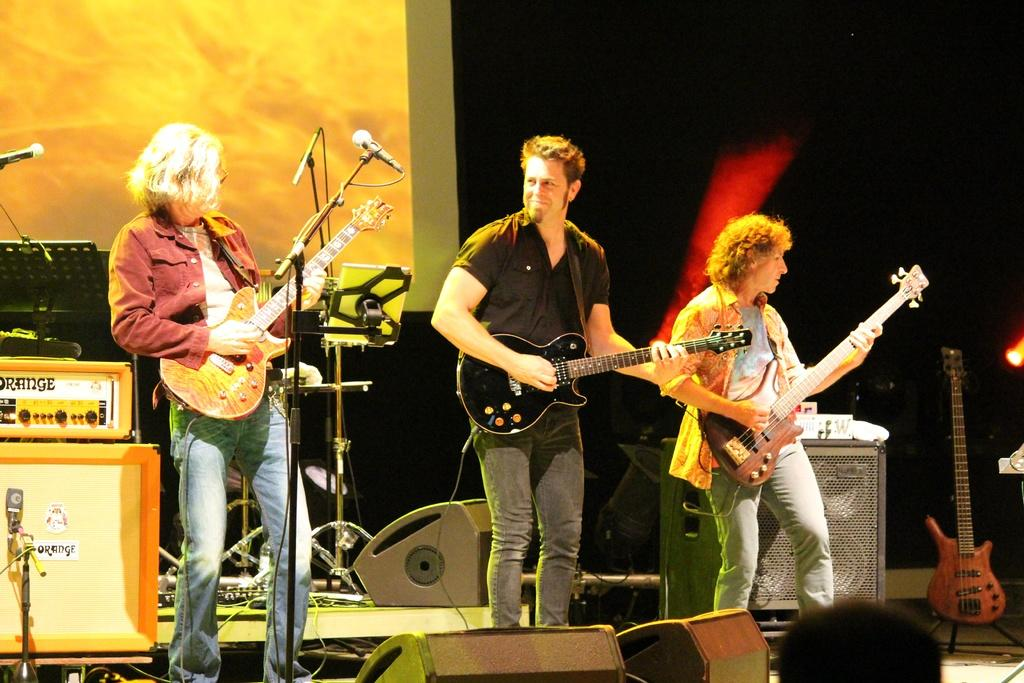How many people are in the image? There are three persons in the image. Where are the persons located? The persons are standing on a stage. What are the persons doing on the stage? The persons are playing guitar. What object is present for amplifying sound? There is a microphone in the image. What other objects are related to music in the image? There are musical instruments in the image. Can you see the ocean in the background of the image? There is no ocean visible in the image; it features a stage with people playing guitar. Is the moon shining on the persons playing guitar in the image? There is no moon present in the image; it is focused on the stage and the people playing guitar. 